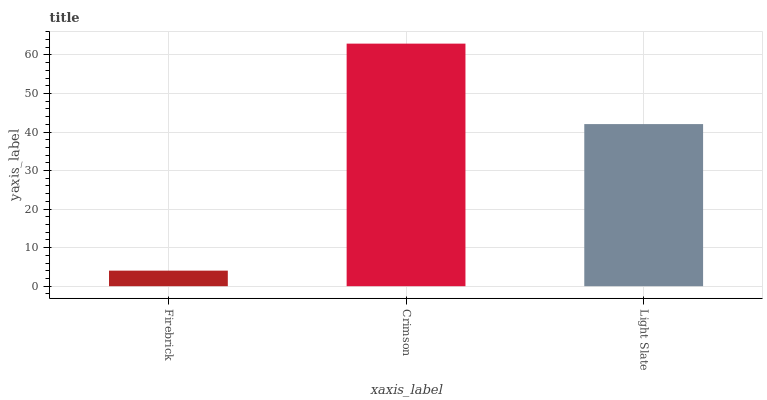Is Firebrick the minimum?
Answer yes or no. Yes. Is Crimson the maximum?
Answer yes or no. Yes. Is Light Slate the minimum?
Answer yes or no. No. Is Light Slate the maximum?
Answer yes or no. No. Is Crimson greater than Light Slate?
Answer yes or no. Yes. Is Light Slate less than Crimson?
Answer yes or no. Yes. Is Light Slate greater than Crimson?
Answer yes or no. No. Is Crimson less than Light Slate?
Answer yes or no. No. Is Light Slate the high median?
Answer yes or no. Yes. Is Light Slate the low median?
Answer yes or no. Yes. Is Crimson the high median?
Answer yes or no. No. Is Crimson the low median?
Answer yes or no. No. 